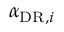<formula> <loc_0><loc_0><loc_500><loc_500>\alpha _ { D R , i }</formula> 